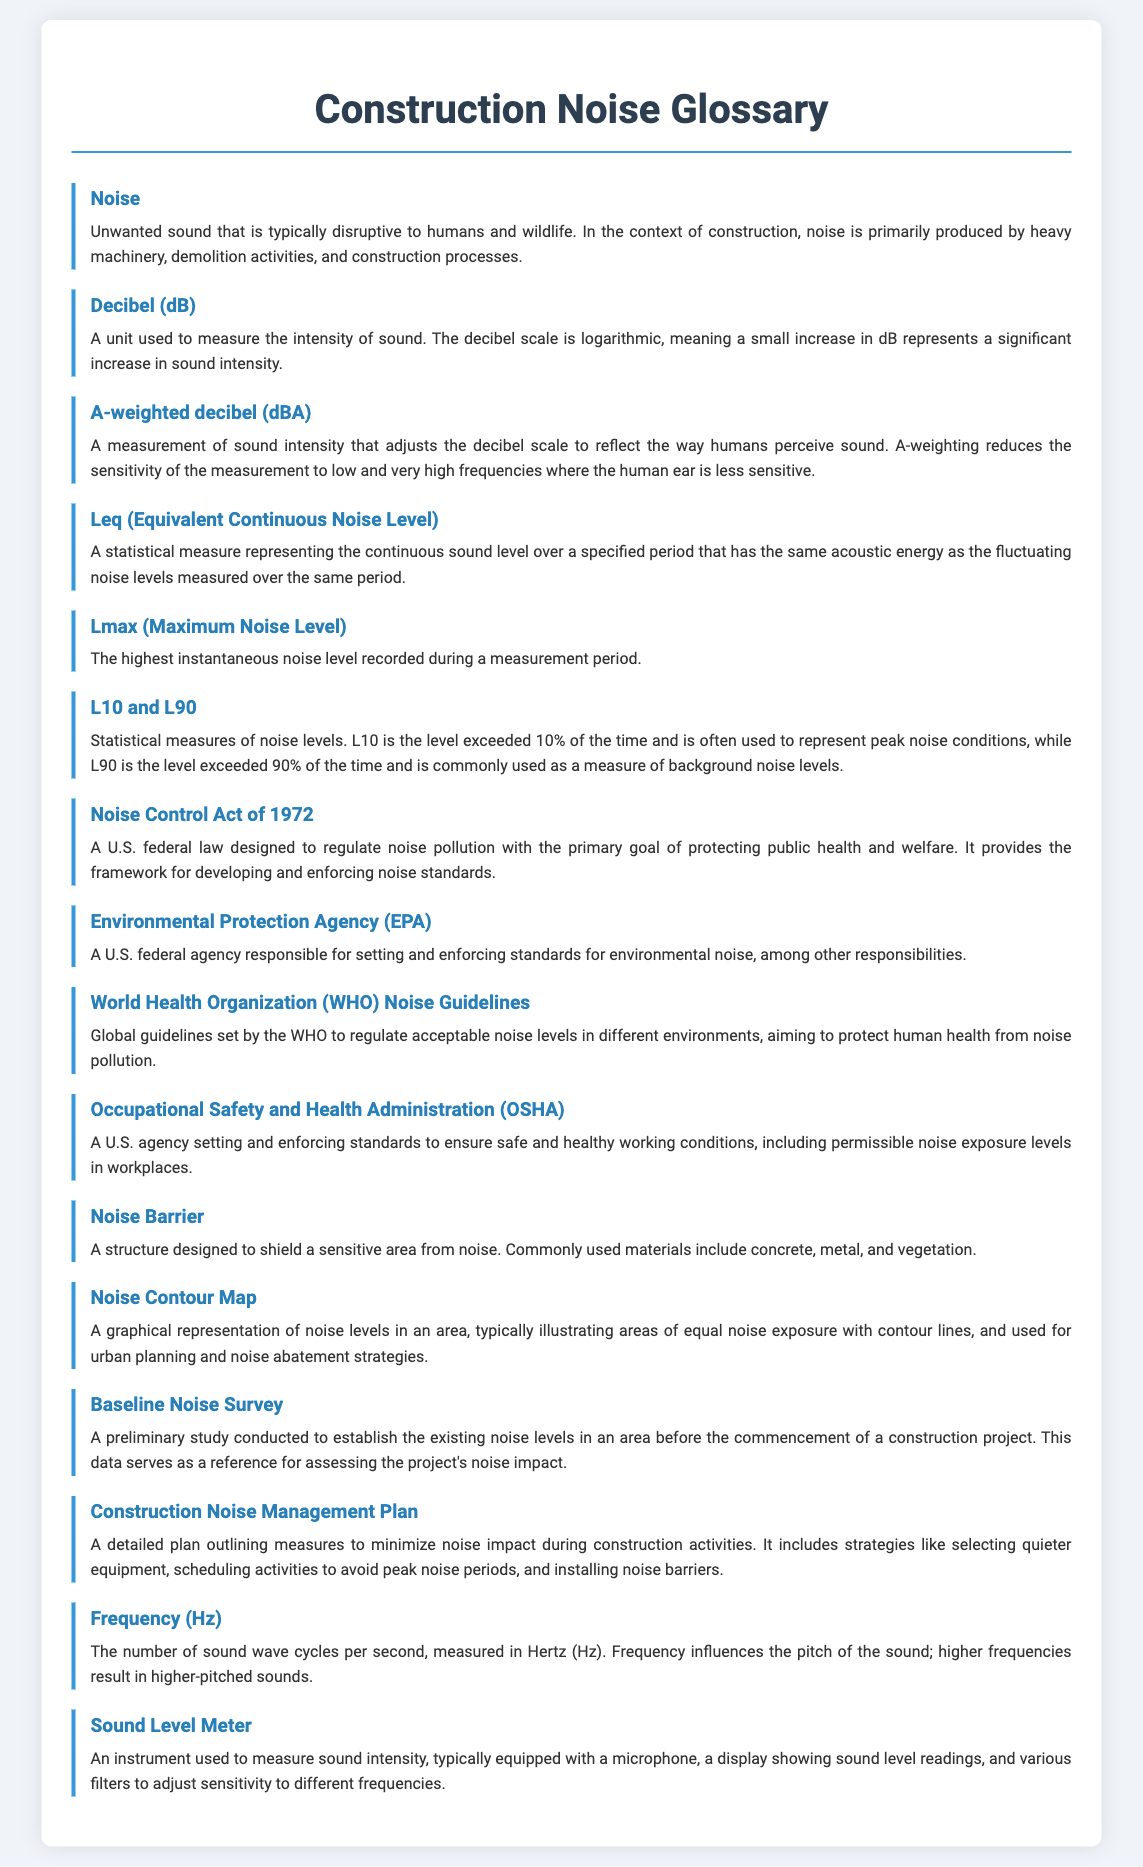What does dBA stand for? dBA is the A-weighted decibel, a measurement of sound intensity that reflects human perception of sound.
Answer: A-weighted decibel (dBA) What is the purpose of the Noise Control Act of 1972? The Noise Control Act of 1972 aims to regulate noise pollution for protecting public health and welfare.
Answer: Regulate noise pollution What is Leq? Leq stands for Equivalent Continuous Noise Level, a statistical measure of continuous sound level.
Answer: Equivalent Continuous Noise Level What agency sets standards for environmental noise? The agency responsible for setting standards for environmental noise is the Environmental Protection Agency.
Answer: Environmental Protection Agency (EPA) What is a Noise Contour Map? A graphical representation of noise levels illustrating areas of equal noise exposure with contour lines.
Answer: Graphical representation What does L10 represent? L10 is the noise level exceeded 10% of the time, used to represent peak noise conditions.
Answer: Noise level exceeded 10% What is the highest instantaneous noise level referred to as? The highest instantaneous noise level recorded is referred to as Lmax.
Answer: Lmax What does a Construction Noise Management Plan include? A Construction Noise Management Plan includes measures to minimize noise impact during construction activities.
Answer: Measures to minimize noise What is the purpose of a Baseline Noise Survey? The purpose of a Baseline Noise Survey is to establish existing noise levels before a construction project starts.
Answer: Establish existing noise levels What does OSHA stand for? OSHA stands for Occupational Safety and Health Administration.
Answer: Occupational Safety and Health Administration (OSHA) 